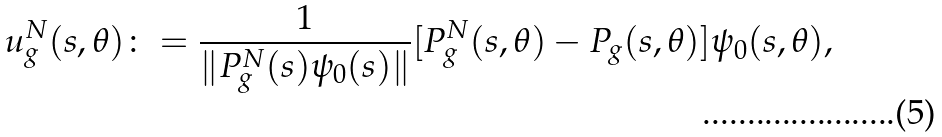<formula> <loc_0><loc_0><loc_500><loc_500>u _ { g } ^ { N } ( s , \theta ) \colon = \frac { 1 } { \| P _ { g } ^ { N } ( s ) \psi _ { 0 } ( s ) \| } [ P _ { g } ^ { N } ( s , \theta ) - P _ { g } ( s , \theta ) ] \psi _ { 0 } ( s , \theta ) ,</formula> 